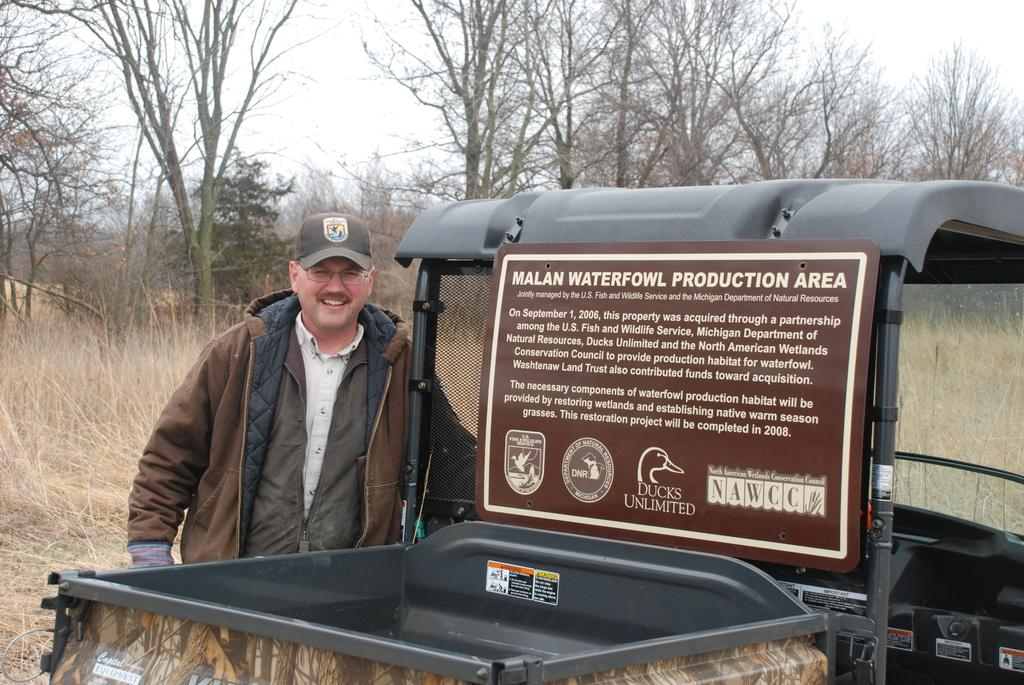Who or what is present in the image? There is a person in the image. What is the person doing or standing near? The person is standing next to a vehicle. What can be seen in the background of the image? There is a group of trees and grass visible in the background of the image. What type of knowledge is being shared at the event in the image? There is no event or knowledge sharing present in the image; it features a person standing next to a vehicle with a background of trees and grass. How many snakes can be seen slithering through the grass in the image? There are no snakes visible in the image; it only shows a person, a vehicle, trees, and grass. 